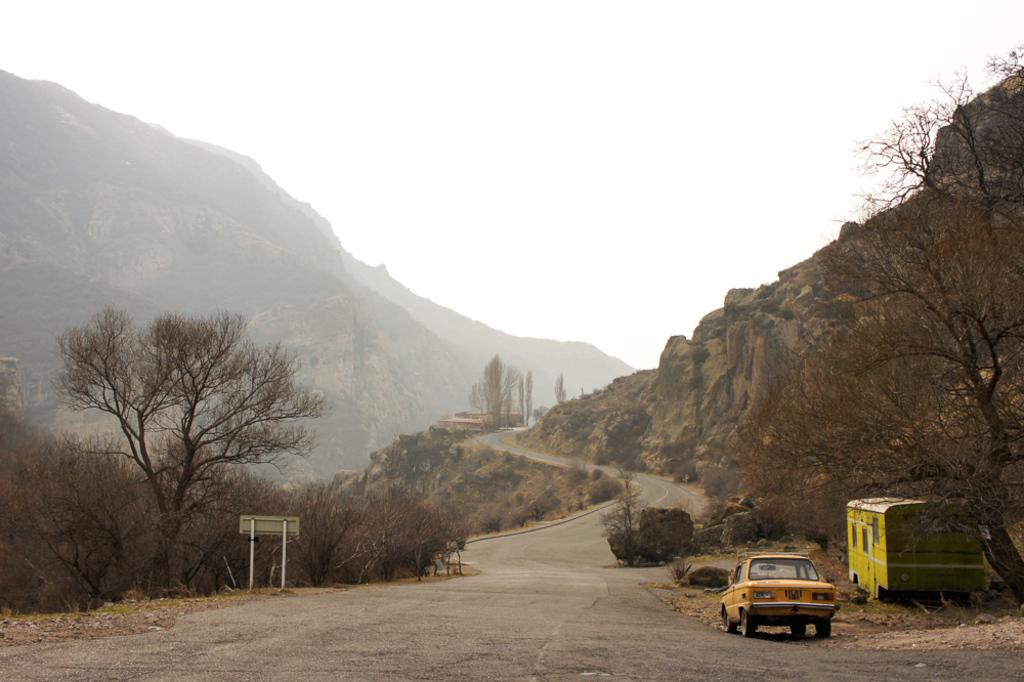What type of natural formation can be seen in the image? There are mountains in the image. What type of vegetation is present in the image? There are plants and grass in the image. What is the main feature in the center of the image? There is a road in the center of the image. What vehicles are present beside the road? There is a bus and a car beside the road. What is the board beside the road used for? The purpose of the board beside the road is not specified in the image. What is visible at the top of the image? The sky is visible at the top of the image. Can you see a monkey swinging from a pump in the image? No, there is no monkey or pump present in the image. What color is the wrist of the person driving the car? There is no person visible in the image, so it is impossible to determine the color of their wrist. 